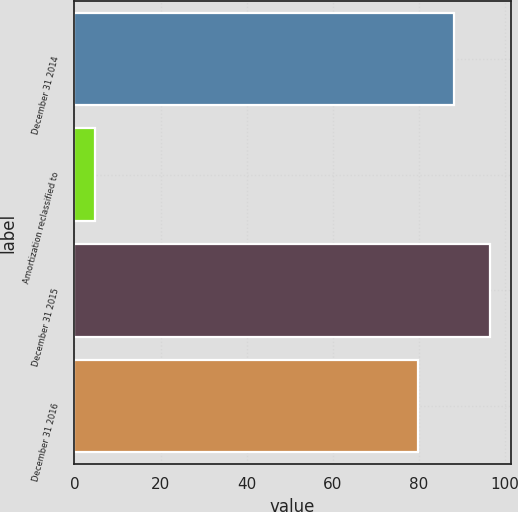Convert chart to OTSL. <chart><loc_0><loc_0><loc_500><loc_500><bar_chart><fcel>December 31 2014<fcel>Amortization reclassified to<fcel>December 31 2015<fcel>December 31 2016<nl><fcel>88.1<fcel>4.9<fcel>96.5<fcel>79.7<nl></chart> 